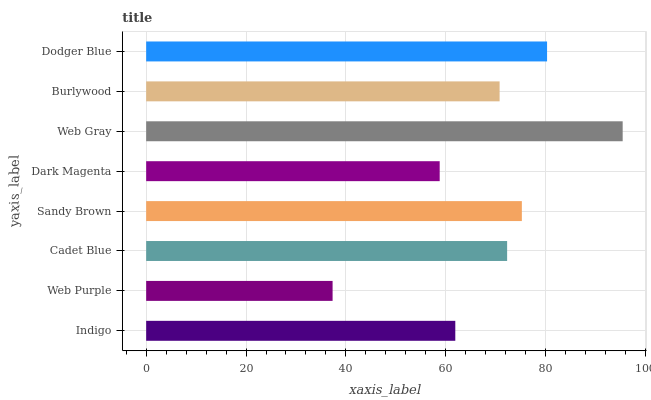Is Web Purple the minimum?
Answer yes or no. Yes. Is Web Gray the maximum?
Answer yes or no. Yes. Is Cadet Blue the minimum?
Answer yes or no. No. Is Cadet Blue the maximum?
Answer yes or no. No. Is Cadet Blue greater than Web Purple?
Answer yes or no. Yes. Is Web Purple less than Cadet Blue?
Answer yes or no. Yes. Is Web Purple greater than Cadet Blue?
Answer yes or no. No. Is Cadet Blue less than Web Purple?
Answer yes or no. No. Is Cadet Blue the high median?
Answer yes or no. Yes. Is Burlywood the low median?
Answer yes or no. Yes. Is Web Gray the high median?
Answer yes or no. No. Is Web Purple the low median?
Answer yes or no. No. 